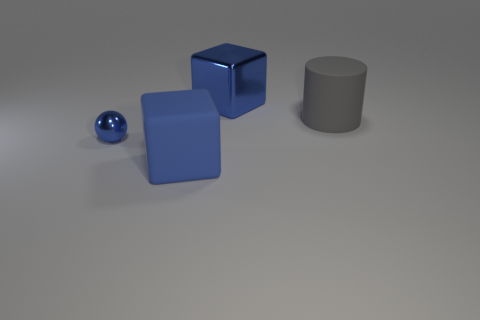What is the size of the matte object that is behind the large blue block to the left of the large blue metal block?
Offer a terse response. Large. Do the big cylinder and the big thing that is in front of the matte cylinder have the same color?
Ensure brevity in your answer.  No. Are there fewer rubber objects to the left of the gray matte cylinder than big blue objects?
Offer a very short reply. Yes. What number of other objects are there of the same size as the blue matte object?
Give a very brief answer. 2. Is the shape of the big metallic thing behind the cylinder the same as  the big gray matte object?
Offer a terse response. No. Is the number of large matte cylinders that are in front of the gray rubber object greater than the number of blue blocks?
Offer a terse response. No. There is a large thing that is both behind the metallic ball and in front of the blue metallic block; what material is it?
Your response must be concise. Rubber. Is there anything else that is the same shape as the large gray matte thing?
Your response must be concise. No. What number of blue things are right of the small metallic ball and in front of the gray thing?
Make the answer very short. 1. What is the material of the ball?
Offer a terse response. Metal. 